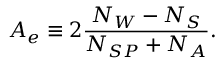<formula> <loc_0><loc_0><loc_500><loc_500>A _ { e } \equiv 2 \frac { N _ { W } - N _ { S } } { N _ { S P } + N _ { A } } .</formula> 